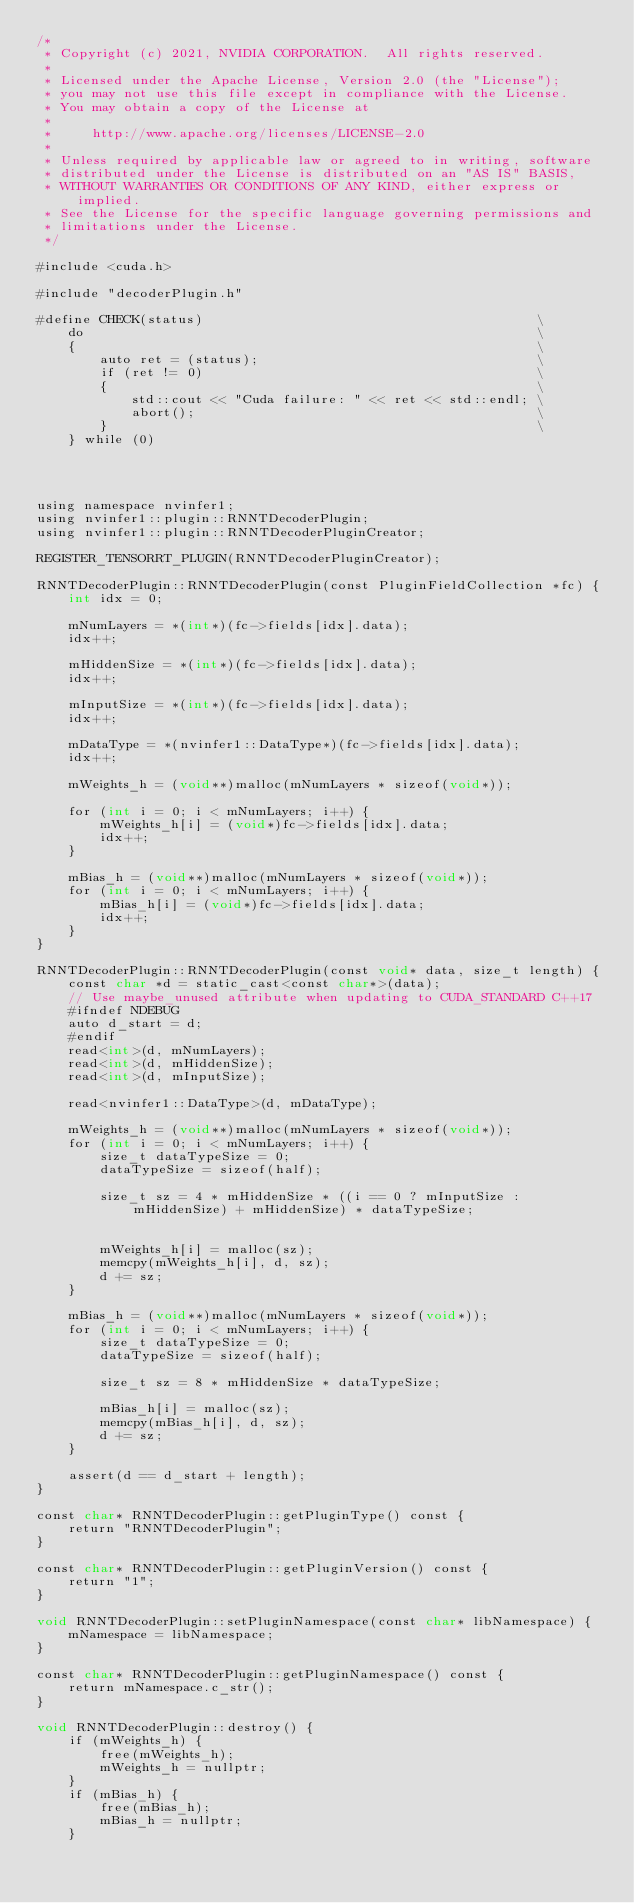<code> <loc_0><loc_0><loc_500><loc_500><_Cuda_>/*
 * Copyright (c) 2021, NVIDIA CORPORATION.  All rights reserved.
 *
 * Licensed under the Apache License, Version 2.0 (the "License");
 * you may not use this file except in compliance with the License.
 * You may obtain a copy of the License at
 *
 *     http://www.apache.org/licenses/LICENSE-2.0
 *
 * Unless required by applicable law or agreed to in writing, software
 * distributed under the License is distributed on an "AS IS" BASIS,
 * WITHOUT WARRANTIES OR CONDITIONS OF ANY KIND, either express or implied.
 * See the License for the specific language governing permissions and
 * limitations under the License.
 */

#include <cuda.h>

#include "decoderPlugin.h"

#define CHECK(status)                                          \
    do                                                         \
    {                                                          \
        auto ret = (status);                                   \
        if (ret != 0)                                          \
        {                                                      \
            std::cout << "Cuda failure: " << ret << std::endl; \
            abort();                                           \
        }                                                      \
    } while (0)




using namespace nvinfer1;
using nvinfer1::plugin::RNNTDecoderPlugin;
using nvinfer1::plugin::RNNTDecoderPluginCreator;

REGISTER_TENSORRT_PLUGIN(RNNTDecoderPluginCreator);

RNNTDecoderPlugin::RNNTDecoderPlugin(const PluginFieldCollection *fc) {
    int idx = 0;
    
    mNumLayers = *(int*)(fc->fields[idx].data);
    idx++;
    
    mHiddenSize = *(int*)(fc->fields[idx].data);
    idx++;
    
    mInputSize = *(int*)(fc->fields[idx].data);
    idx++;
    
    mDataType = *(nvinfer1::DataType*)(fc->fields[idx].data);
    idx++;
    
    mWeights_h = (void**)malloc(mNumLayers * sizeof(void*));
    
    for (int i = 0; i < mNumLayers; i++) {        
        mWeights_h[i] = (void*)fc->fields[idx].data;
        idx++;
    }
    
    mBias_h = (void**)malloc(mNumLayers * sizeof(void*));
    for (int i = 0; i < mNumLayers; i++) {        
        mBias_h[i] = (void*)fc->fields[idx].data;
        idx++;
    }
}

RNNTDecoderPlugin::RNNTDecoderPlugin(const void* data, size_t length) {
    const char *d = static_cast<const char*>(data);
    // Use maybe_unused attribute when updating to CUDA_STANDARD C++17
    #ifndef NDEBUG
    auto d_start = d;
    #endif
    read<int>(d, mNumLayers);
    read<int>(d, mHiddenSize);
    read<int>(d, mInputSize);
    
    read<nvinfer1::DataType>(d, mDataType);
    
    mWeights_h = (void**)malloc(mNumLayers * sizeof(void*));
    for (int i = 0; i < mNumLayers; i++) {        
        size_t dataTypeSize = 0;
        dataTypeSize = sizeof(half);
        
        size_t sz = 4 * mHiddenSize * ((i == 0 ? mInputSize : mHiddenSize) + mHiddenSize) * dataTypeSize;
               

        mWeights_h[i] = malloc(sz);
        memcpy(mWeights_h[i], d, sz);
        d += sz;
    }
    
    mBias_h = (void**)malloc(mNumLayers * sizeof(void*));
    for (int i = 0; i < mNumLayers; i++) {        
        size_t dataTypeSize = 0;
        dataTypeSize = sizeof(half);
        
        size_t sz = 8 * mHiddenSize * dataTypeSize;

        mBias_h[i] = malloc(sz);
        memcpy(mBias_h[i], d, sz);
        d += sz;
    }
    
    assert(d == d_start + length);
}

const char* RNNTDecoderPlugin::getPluginType() const {
    return "RNNTDecoderPlugin";
}

const char* RNNTDecoderPlugin::getPluginVersion() const {
    return "1";
}

void RNNTDecoderPlugin::setPluginNamespace(const char* libNamespace) {
    mNamespace = libNamespace;
}

const char* RNNTDecoderPlugin::getPluginNamespace() const {
    return mNamespace.c_str();
}

void RNNTDecoderPlugin::destroy() {
    if (mWeights_h) {
        free(mWeights_h);
        mWeights_h = nullptr;
    }
    if (mBias_h) {
        free(mBias_h);
        mBias_h = nullptr;
    }</code> 